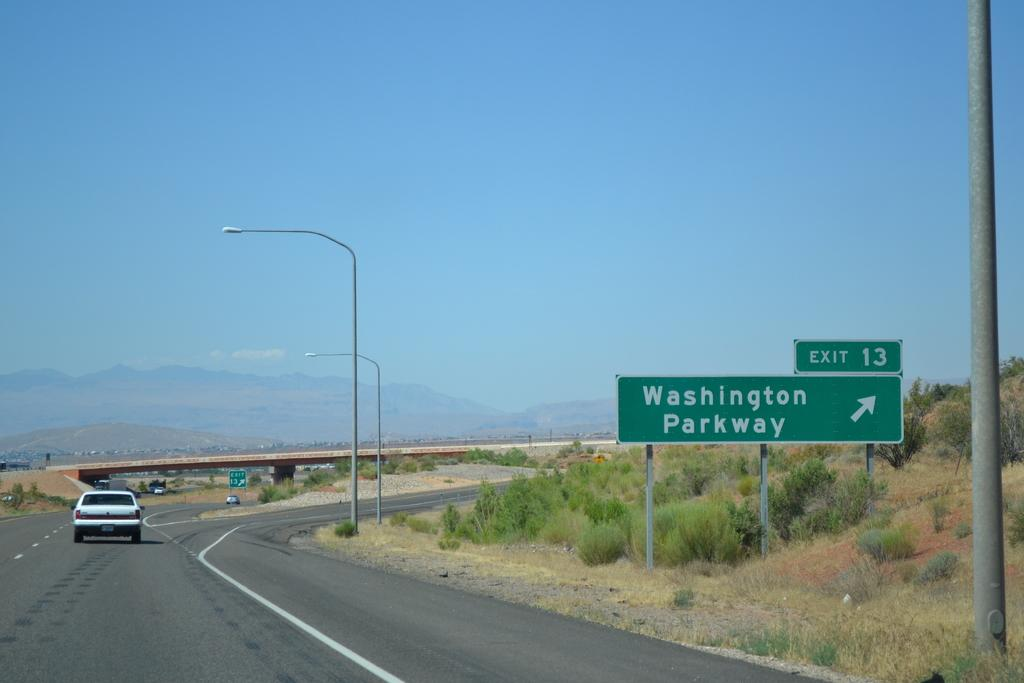<image>
Present a compact description of the photo's key features. A highway scene that shows exit 13 to Washington Parkway is  on the right. 